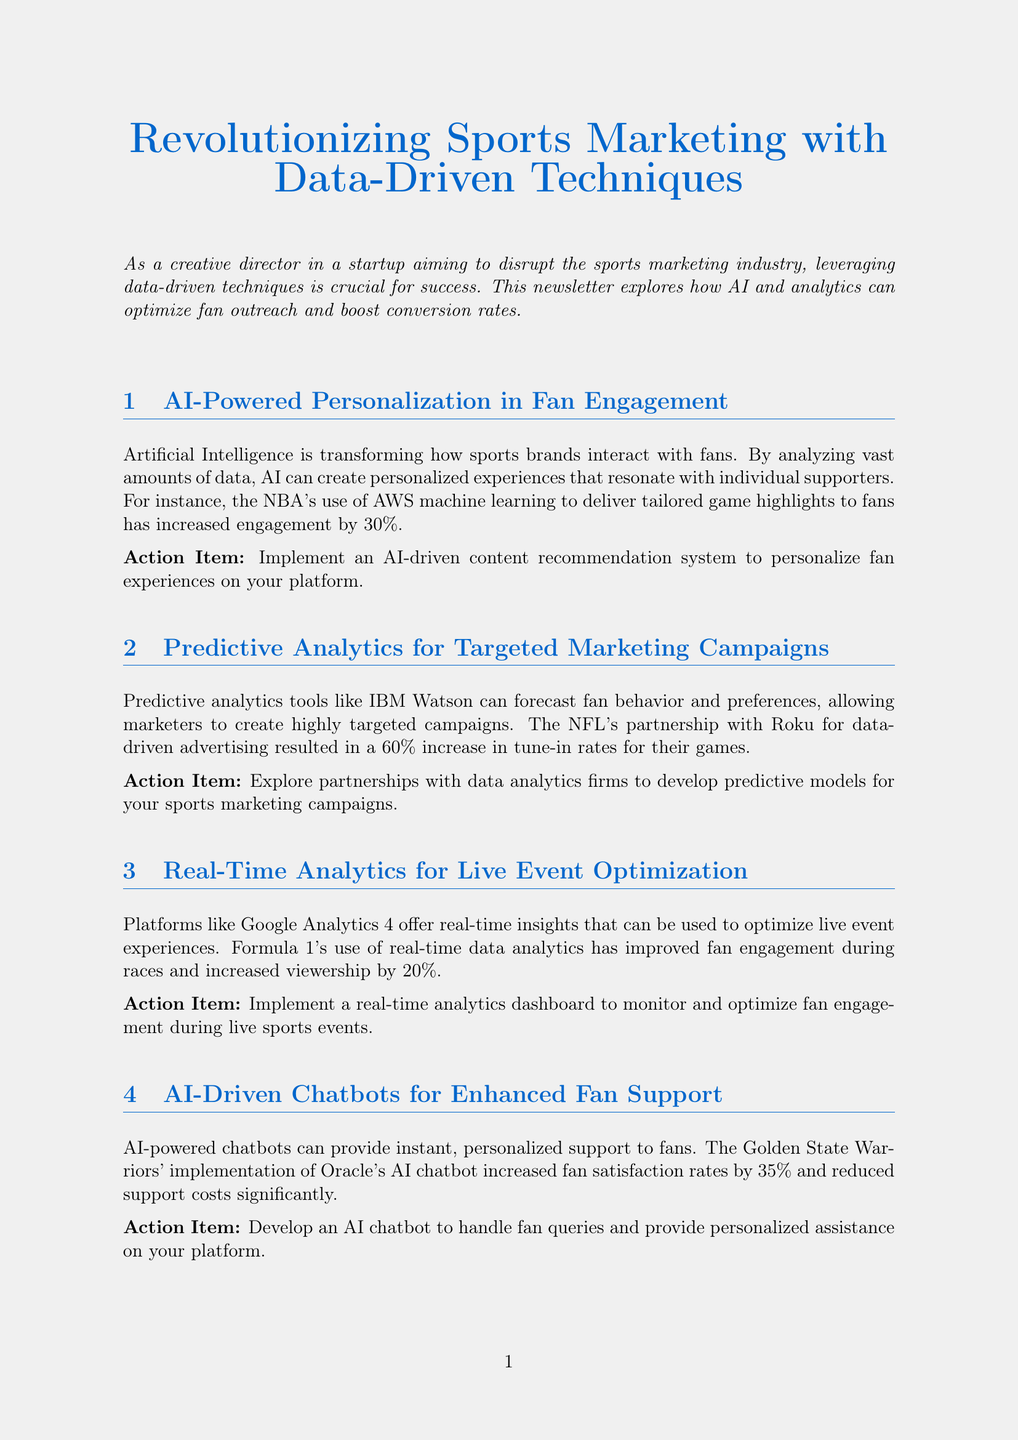What is the title of the newsletter? The title of the newsletter is specifically mentioned at the beginning of the document.
Answer: Revolutionizing Sports Marketing with Data-Driven Techniques What percentage increase in engagement did the NBA achieve? The NBA's case study explicitly states the percentage increase in engagement as a result of using AI.
Answer: 30% What is one action item suggested for AI-powered personalization? The document outlines specific actions to take in each section, including AI-powered personalization.
Answer: Implement an AI-driven content recommendation system to personalize fan experiences on your platform How much did merchandise sales increase for Manchester City FC? The success story for Manchester City FC provides a specific percentage increase in merchandise sales following their initiative.
Answer: 13% Who is quoted in the newsletter? The quote section of the document states the name of the expert providing insight on the topic discussed.
Answer: Jessica Smith What technology is mentioned alongside AI for upcoming trends? The upcoming trends section lists technologies that will influence the sports marketing field, specifically mentioning a trend involving AI.
Answer: AR/VR technologies What was the increase in tune-in rates for the NFL's partnership with Roku? The document states the specific increase in tune-in rates due to the NFL's marketing efforts shared in the predictive analytics section.
Answer: 60% What is a key takeaway from the Manchester City FC case study? The key takeaways section summarizes important points learned from the case study, reflecting on effective marketing strategies.
Answer: Centralized data management is crucial for effective analysis What type of analytics does Google Analytics 4 provide? The content describes the capabilities of Google Analytics 4 in the context of live event optimization.
Answer: Real-time insights 